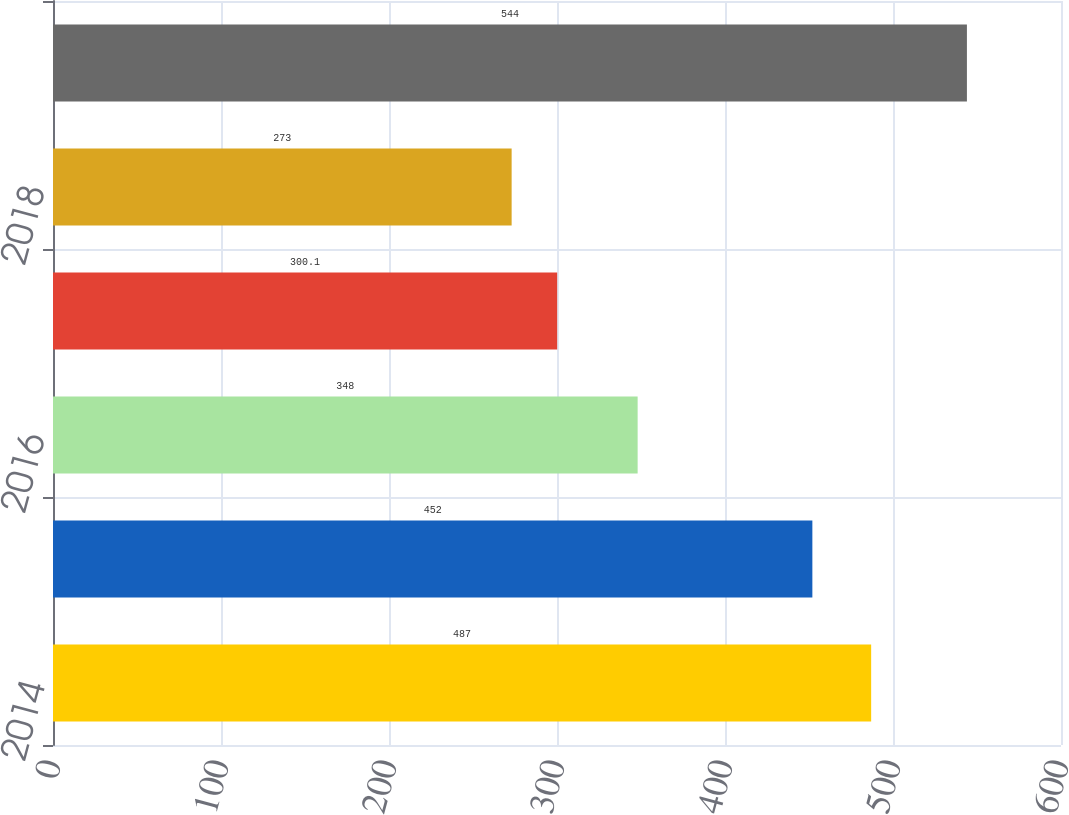<chart> <loc_0><loc_0><loc_500><loc_500><bar_chart><fcel>2014<fcel>2015<fcel>2016<fcel>2017<fcel>2018<fcel>Thereafter<nl><fcel>487<fcel>452<fcel>348<fcel>300.1<fcel>273<fcel>544<nl></chart> 